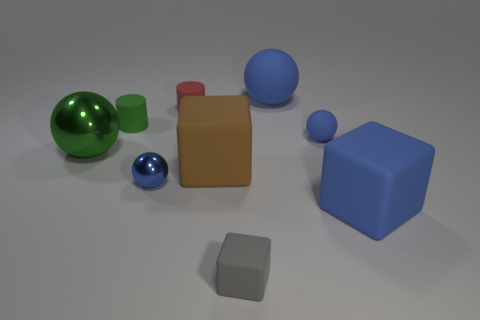There is a tiny matte thing that is the same color as the small shiny sphere; what is its shape?
Your response must be concise. Sphere. There is a shiny ball in front of the brown thing; is its color the same as the tiny matte ball?
Provide a short and direct response. Yes. The small matte object on the right side of the large blue sphere that is behind the big blue matte cube is what shape?
Your answer should be very brief. Sphere. What number of things are either tiny rubber cylinders that are left of the tiny red matte cylinder or large blue matte things in front of the brown block?
Offer a terse response. 2. The small red object that is the same material as the tiny green thing is what shape?
Offer a terse response. Cylinder. Is there any other thing that has the same color as the small metal sphere?
Your response must be concise. Yes. There is a large blue object that is the same shape as the large green thing; what is it made of?
Give a very brief answer. Rubber. How many other things are the same size as the green ball?
Your answer should be compact. 3. What is the gray object made of?
Provide a succinct answer. Rubber. Are there more tiny green things that are on the right side of the gray thing than gray cubes?
Offer a very short reply. No. 